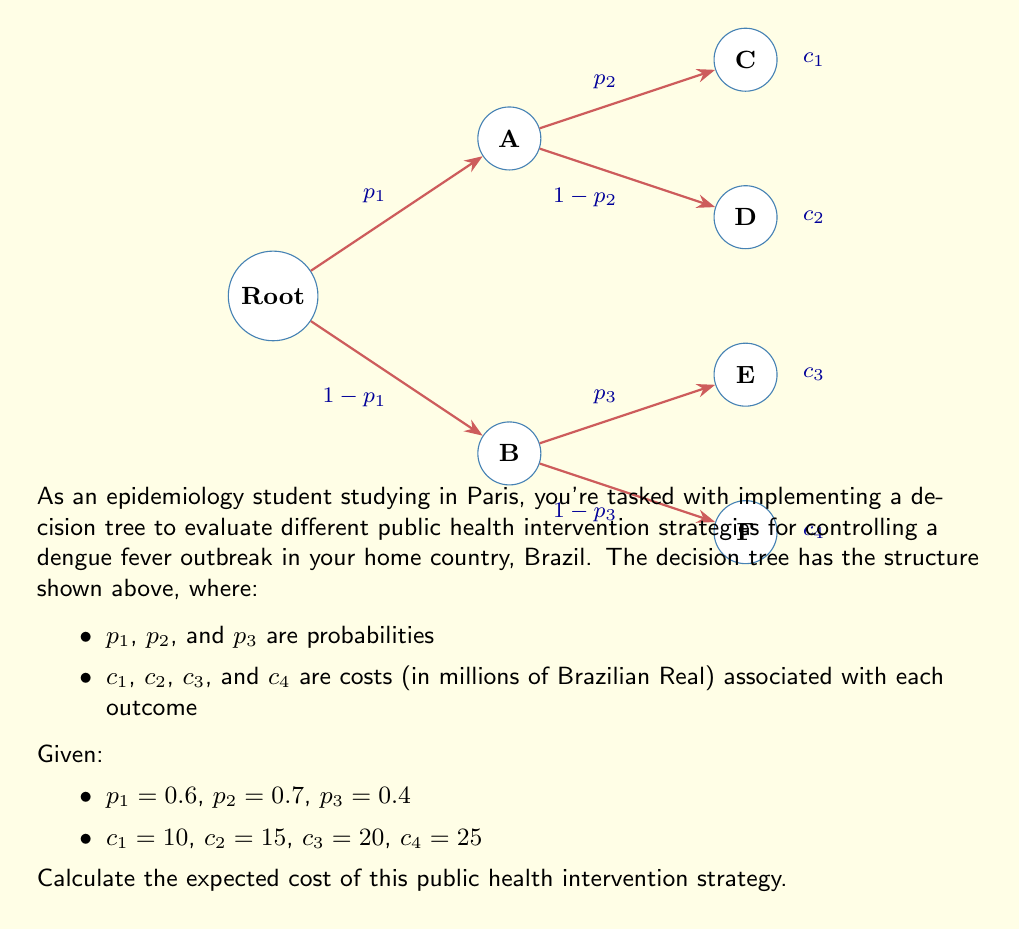What is the answer to this math problem? To calculate the expected cost of the public health intervention strategy, we need to follow these steps:

1) First, let's calculate the probability of reaching each end node (C, D, E, F):

   P(C) = $p_1 \times p_2 = 0.6 \times 0.7 = 0.42$
   P(D) = $p_1 \times (1-p_2) = 0.6 \times 0.3 = 0.18$
   P(E) = $(1-p_1) \times p_3 = 0.4 \times 0.4 = 0.16$
   P(F) = $(1-p_1) \times (1-p_3) = 0.4 \times 0.6 = 0.24$

2) Now, we multiply each probability by its associated cost:

   C: $0.42 \times 10 = 4.2$
   D: $0.18 \times 15 = 2.7$
   E: $0.16 \times 20 = 3.2$
   F: $0.24 \times 25 = 6.0$

3) The expected cost is the sum of these values:

   Expected Cost = $4.2 + 2.7 + 3.2 + 6.0 = 16.1$

Therefore, the expected cost of this public health intervention strategy is 16.1 million Brazilian Real.
Answer: 16.1 million Brazilian Real 